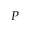Convert formula to latex. <formula><loc_0><loc_0><loc_500><loc_500>P</formula> 